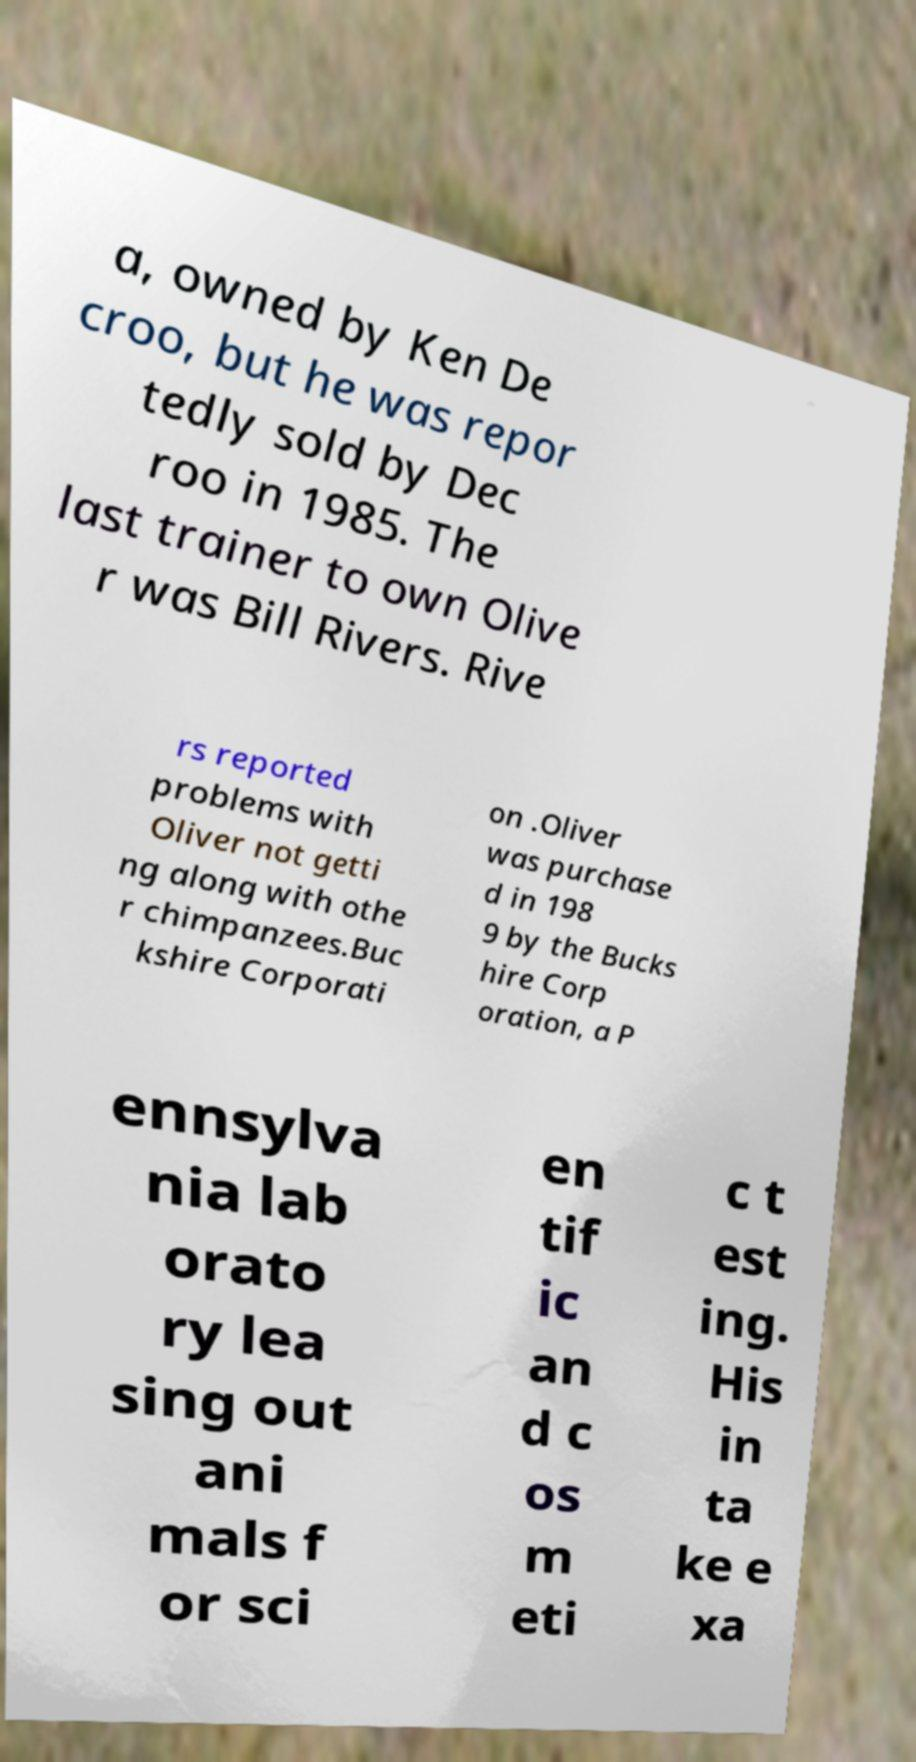I need the written content from this picture converted into text. Can you do that? a, owned by Ken De croo, but he was repor tedly sold by Dec roo in 1985. The last trainer to own Olive r was Bill Rivers. Rive rs reported problems with Oliver not getti ng along with othe r chimpanzees.Buc kshire Corporati on .Oliver was purchase d in 198 9 by the Bucks hire Corp oration, a P ennsylva nia lab orato ry lea sing out ani mals f or sci en tif ic an d c os m eti c t est ing. His in ta ke e xa 